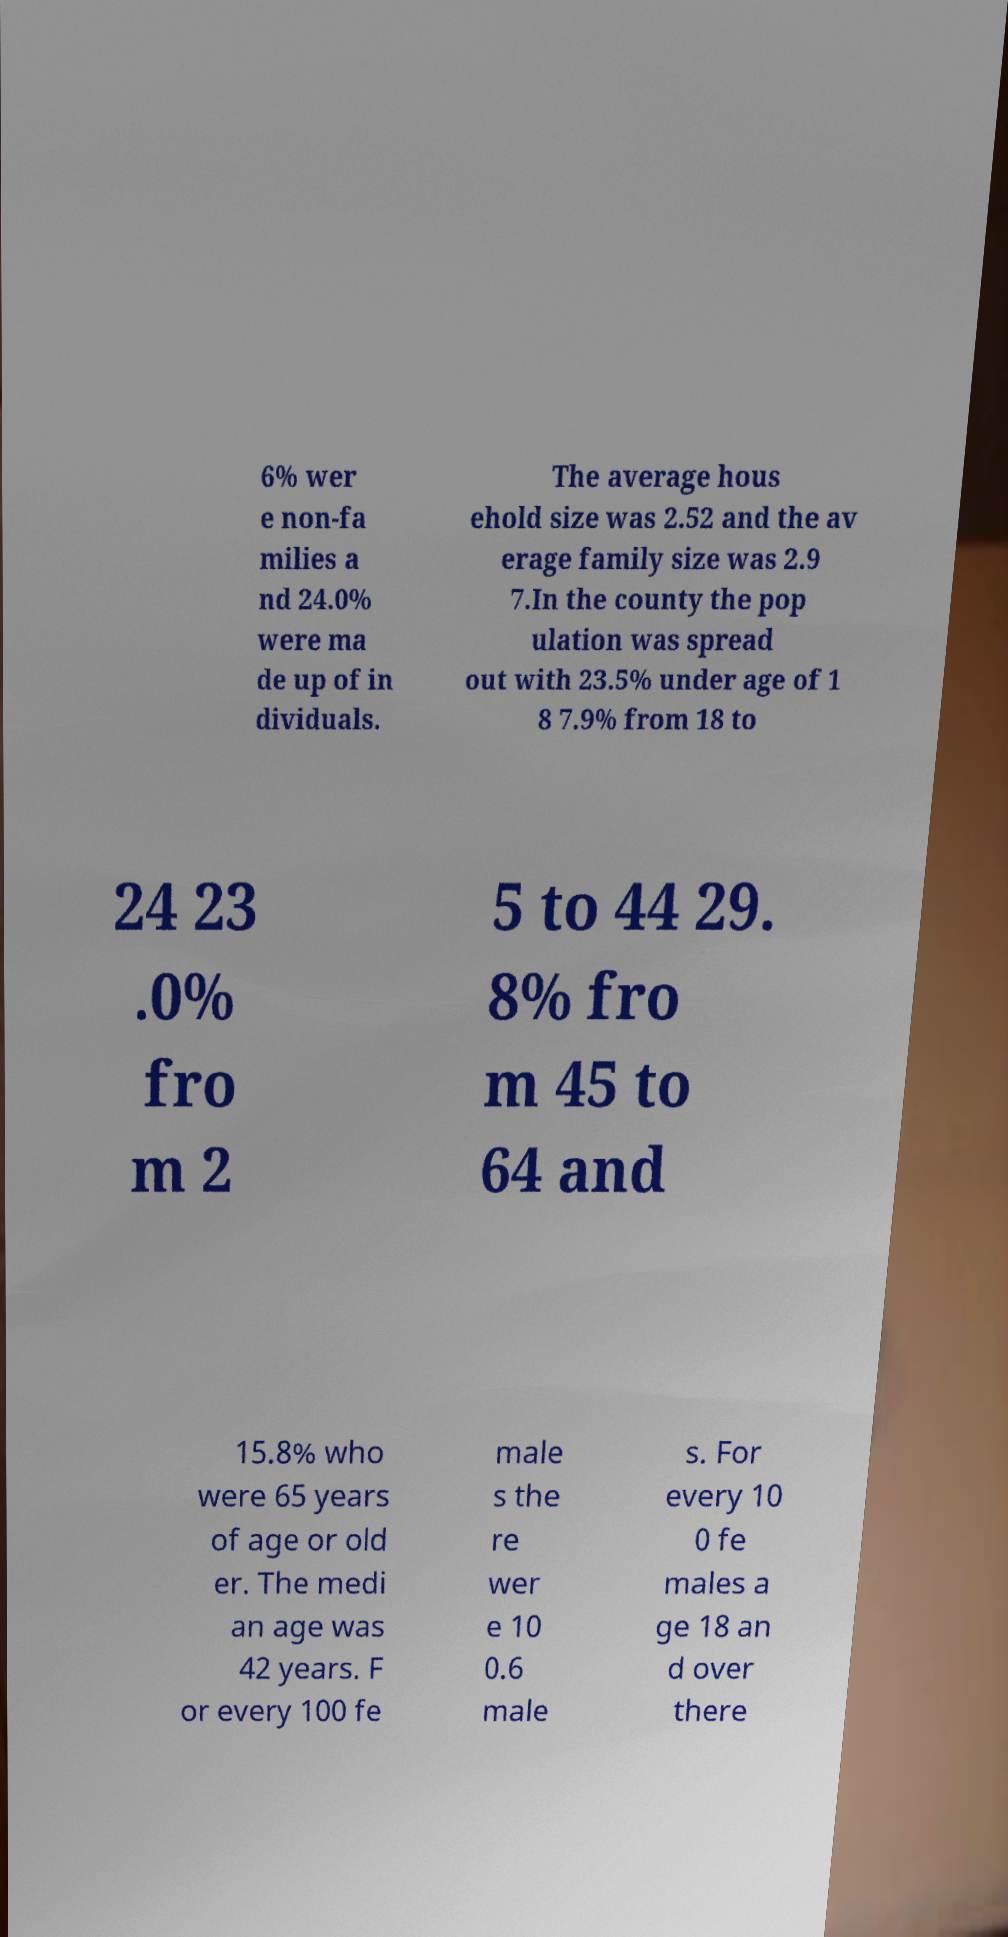I need the written content from this picture converted into text. Can you do that? 6% wer e non-fa milies a nd 24.0% were ma de up of in dividuals. The average hous ehold size was 2.52 and the av erage family size was 2.9 7.In the county the pop ulation was spread out with 23.5% under age of 1 8 7.9% from 18 to 24 23 .0% fro m 2 5 to 44 29. 8% fro m 45 to 64 and 15.8% who were 65 years of age or old er. The medi an age was 42 years. F or every 100 fe male s the re wer e 10 0.6 male s. For every 10 0 fe males a ge 18 an d over there 